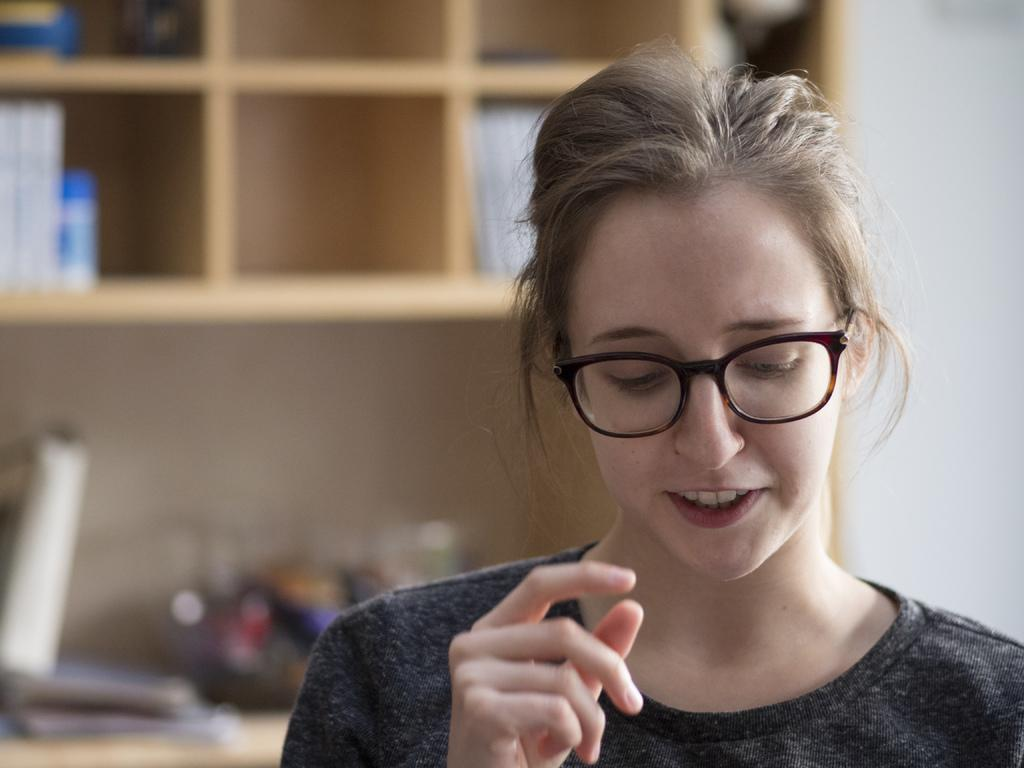Who is present in the image? There is a person in the image. What can be seen on the person's face? The person is wearing spectacles. What is visible in the background of the image? There are shelves with objects in the background. What type of structure is visible in the image? There is a wall visible in the image. What type of impulse can be seen affecting the person in the image? There is no impulse affecting the person in the image; it is a still photograph. Can you see a mountain in the background of the image? There is no mountain visible in the image; only shelves with objects and a wall are present. 